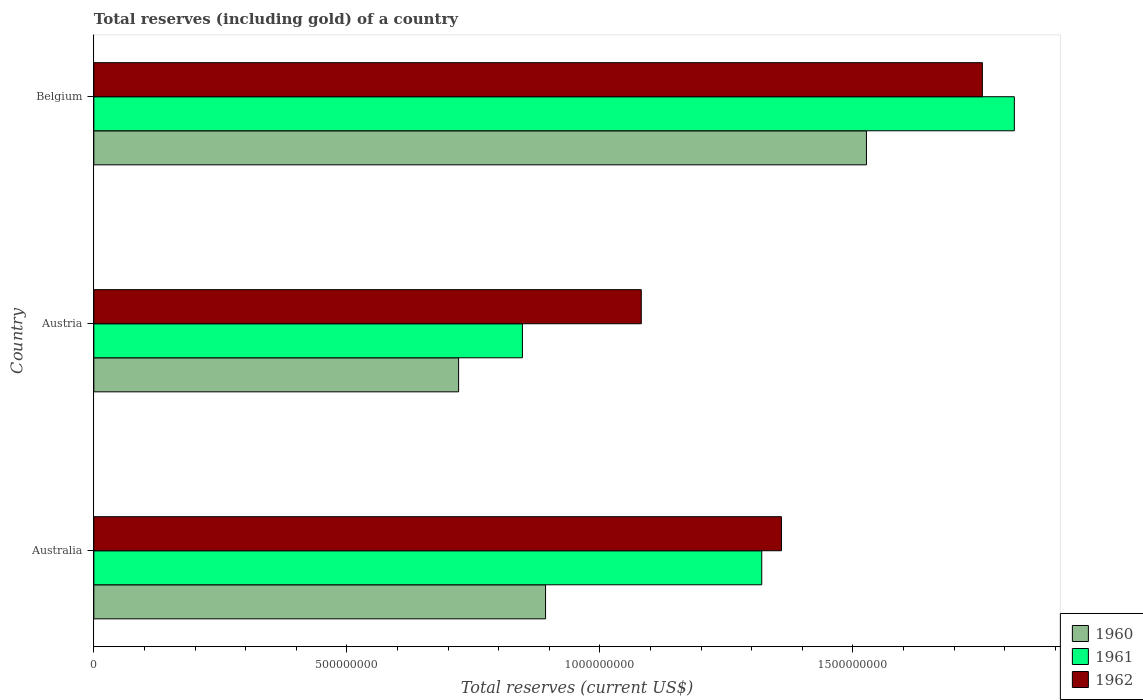Are the number of bars on each tick of the Y-axis equal?
Give a very brief answer. Yes. How many bars are there on the 1st tick from the top?
Your answer should be very brief. 3. How many bars are there on the 3rd tick from the bottom?
Provide a short and direct response. 3. What is the label of the 2nd group of bars from the top?
Ensure brevity in your answer.  Austria. In how many cases, is the number of bars for a given country not equal to the number of legend labels?
Provide a short and direct response. 0. What is the total reserves (including gold) in 1962 in Australia?
Your response must be concise. 1.36e+09. Across all countries, what is the maximum total reserves (including gold) in 1962?
Make the answer very short. 1.76e+09. Across all countries, what is the minimum total reserves (including gold) in 1962?
Give a very brief answer. 1.08e+09. In which country was the total reserves (including gold) in 1960 minimum?
Ensure brevity in your answer.  Austria. What is the total total reserves (including gold) in 1961 in the graph?
Offer a terse response. 3.99e+09. What is the difference between the total reserves (including gold) in 1960 in Australia and that in Belgium?
Your response must be concise. -6.34e+08. What is the difference between the total reserves (including gold) in 1961 in Australia and the total reserves (including gold) in 1962 in Belgium?
Ensure brevity in your answer.  -4.36e+08. What is the average total reserves (including gold) in 1962 per country?
Your answer should be compact. 1.40e+09. What is the difference between the total reserves (including gold) in 1960 and total reserves (including gold) in 1962 in Austria?
Your answer should be compact. -3.61e+08. What is the ratio of the total reserves (including gold) in 1961 in Austria to that in Belgium?
Provide a short and direct response. 0.47. What is the difference between the highest and the second highest total reserves (including gold) in 1961?
Make the answer very short. 4.99e+08. What is the difference between the highest and the lowest total reserves (including gold) in 1961?
Offer a very short reply. 9.72e+08. Is the sum of the total reserves (including gold) in 1960 in Austria and Belgium greater than the maximum total reserves (including gold) in 1962 across all countries?
Your response must be concise. Yes. What does the 1st bar from the top in Austria represents?
Provide a succinct answer. 1962. How many bars are there?
Provide a succinct answer. 9. Are all the bars in the graph horizontal?
Keep it short and to the point. Yes. Does the graph contain grids?
Your response must be concise. No. How many legend labels are there?
Offer a terse response. 3. How are the legend labels stacked?
Offer a very short reply. Vertical. What is the title of the graph?
Your answer should be very brief. Total reserves (including gold) of a country. What is the label or title of the X-axis?
Ensure brevity in your answer.  Total reserves (current US$). What is the Total reserves (current US$) in 1960 in Australia?
Ensure brevity in your answer.  8.93e+08. What is the Total reserves (current US$) in 1961 in Australia?
Ensure brevity in your answer.  1.32e+09. What is the Total reserves (current US$) in 1962 in Australia?
Offer a terse response. 1.36e+09. What is the Total reserves (current US$) in 1960 in Austria?
Provide a short and direct response. 7.21e+08. What is the Total reserves (current US$) of 1961 in Austria?
Your answer should be very brief. 8.47e+08. What is the Total reserves (current US$) in 1962 in Austria?
Your response must be concise. 1.08e+09. What is the Total reserves (current US$) in 1960 in Belgium?
Keep it short and to the point. 1.53e+09. What is the Total reserves (current US$) in 1961 in Belgium?
Keep it short and to the point. 1.82e+09. What is the Total reserves (current US$) in 1962 in Belgium?
Make the answer very short. 1.76e+09. Across all countries, what is the maximum Total reserves (current US$) of 1960?
Offer a terse response. 1.53e+09. Across all countries, what is the maximum Total reserves (current US$) in 1961?
Offer a terse response. 1.82e+09. Across all countries, what is the maximum Total reserves (current US$) in 1962?
Keep it short and to the point. 1.76e+09. Across all countries, what is the minimum Total reserves (current US$) in 1960?
Provide a succinct answer. 7.21e+08. Across all countries, what is the minimum Total reserves (current US$) of 1961?
Your answer should be compact. 8.47e+08. Across all countries, what is the minimum Total reserves (current US$) of 1962?
Provide a succinct answer. 1.08e+09. What is the total Total reserves (current US$) in 1960 in the graph?
Make the answer very short. 3.14e+09. What is the total Total reserves (current US$) in 1961 in the graph?
Make the answer very short. 3.99e+09. What is the total Total reserves (current US$) of 1962 in the graph?
Your response must be concise. 4.20e+09. What is the difference between the Total reserves (current US$) in 1960 in Australia and that in Austria?
Provide a short and direct response. 1.72e+08. What is the difference between the Total reserves (current US$) in 1961 in Australia and that in Austria?
Give a very brief answer. 4.73e+08. What is the difference between the Total reserves (current US$) in 1962 in Australia and that in Austria?
Provide a succinct answer. 2.77e+08. What is the difference between the Total reserves (current US$) in 1960 in Australia and that in Belgium?
Give a very brief answer. -6.34e+08. What is the difference between the Total reserves (current US$) in 1961 in Australia and that in Belgium?
Ensure brevity in your answer.  -4.99e+08. What is the difference between the Total reserves (current US$) of 1962 in Australia and that in Belgium?
Ensure brevity in your answer.  -3.97e+08. What is the difference between the Total reserves (current US$) in 1960 in Austria and that in Belgium?
Make the answer very short. -8.06e+08. What is the difference between the Total reserves (current US$) of 1961 in Austria and that in Belgium?
Provide a succinct answer. -9.72e+08. What is the difference between the Total reserves (current US$) in 1962 in Austria and that in Belgium?
Offer a very short reply. -6.74e+08. What is the difference between the Total reserves (current US$) in 1960 in Australia and the Total reserves (current US$) in 1961 in Austria?
Your answer should be very brief. 4.57e+07. What is the difference between the Total reserves (current US$) in 1960 in Australia and the Total reserves (current US$) in 1962 in Austria?
Offer a terse response. -1.89e+08. What is the difference between the Total reserves (current US$) of 1961 in Australia and the Total reserves (current US$) of 1962 in Austria?
Give a very brief answer. 2.38e+08. What is the difference between the Total reserves (current US$) in 1960 in Australia and the Total reserves (current US$) in 1961 in Belgium?
Keep it short and to the point. -9.26e+08. What is the difference between the Total reserves (current US$) of 1960 in Australia and the Total reserves (current US$) of 1962 in Belgium?
Give a very brief answer. -8.63e+08. What is the difference between the Total reserves (current US$) of 1961 in Australia and the Total reserves (current US$) of 1962 in Belgium?
Provide a short and direct response. -4.36e+08. What is the difference between the Total reserves (current US$) in 1960 in Austria and the Total reserves (current US$) in 1961 in Belgium?
Make the answer very short. -1.10e+09. What is the difference between the Total reserves (current US$) in 1960 in Austria and the Total reserves (current US$) in 1962 in Belgium?
Your answer should be compact. -1.04e+09. What is the difference between the Total reserves (current US$) of 1961 in Austria and the Total reserves (current US$) of 1962 in Belgium?
Your answer should be very brief. -9.09e+08. What is the average Total reserves (current US$) of 1960 per country?
Give a very brief answer. 1.05e+09. What is the average Total reserves (current US$) of 1961 per country?
Make the answer very short. 1.33e+09. What is the average Total reserves (current US$) of 1962 per country?
Offer a very short reply. 1.40e+09. What is the difference between the Total reserves (current US$) in 1960 and Total reserves (current US$) in 1961 in Australia?
Provide a short and direct response. -4.27e+08. What is the difference between the Total reserves (current US$) of 1960 and Total reserves (current US$) of 1962 in Australia?
Your answer should be compact. -4.66e+08. What is the difference between the Total reserves (current US$) in 1961 and Total reserves (current US$) in 1962 in Australia?
Provide a short and direct response. -3.89e+07. What is the difference between the Total reserves (current US$) in 1960 and Total reserves (current US$) in 1961 in Austria?
Keep it short and to the point. -1.26e+08. What is the difference between the Total reserves (current US$) of 1960 and Total reserves (current US$) of 1962 in Austria?
Give a very brief answer. -3.61e+08. What is the difference between the Total reserves (current US$) of 1961 and Total reserves (current US$) of 1962 in Austria?
Your answer should be very brief. -2.35e+08. What is the difference between the Total reserves (current US$) in 1960 and Total reserves (current US$) in 1961 in Belgium?
Provide a succinct answer. -2.92e+08. What is the difference between the Total reserves (current US$) in 1960 and Total reserves (current US$) in 1962 in Belgium?
Make the answer very short. -2.29e+08. What is the difference between the Total reserves (current US$) of 1961 and Total reserves (current US$) of 1962 in Belgium?
Make the answer very short. 6.32e+07. What is the ratio of the Total reserves (current US$) in 1960 in Australia to that in Austria?
Keep it short and to the point. 1.24. What is the ratio of the Total reserves (current US$) of 1961 in Australia to that in Austria?
Your answer should be compact. 1.56. What is the ratio of the Total reserves (current US$) of 1962 in Australia to that in Austria?
Keep it short and to the point. 1.26. What is the ratio of the Total reserves (current US$) of 1960 in Australia to that in Belgium?
Give a very brief answer. 0.58. What is the ratio of the Total reserves (current US$) in 1961 in Australia to that in Belgium?
Your answer should be very brief. 0.73. What is the ratio of the Total reserves (current US$) in 1962 in Australia to that in Belgium?
Offer a very short reply. 0.77. What is the ratio of the Total reserves (current US$) of 1960 in Austria to that in Belgium?
Give a very brief answer. 0.47. What is the ratio of the Total reserves (current US$) in 1961 in Austria to that in Belgium?
Your answer should be compact. 0.47. What is the ratio of the Total reserves (current US$) in 1962 in Austria to that in Belgium?
Offer a terse response. 0.62. What is the difference between the highest and the second highest Total reserves (current US$) in 1960?
Your answer should be compact. 6.34e+08. What is the difference between the highest and the second highest Total reserves (current US$) in 1961?
Your answer should be very brief. 4.99e+08. What is the difference between the highest and the second highest Total reserves (current US$) of 1962?
Make the answer very short. 3.97e+08. What is the difference between the highest and the lowest Total reserves (current US$) in 1960?
Your answer should be very brief. 8.06e+08. What is the difference between the highest and the lowest Total reserves (current US$) in 1961?
Provide a succinct answer. 9.72e+08. What is the difference between the highest and the lowest Total reserves (current US$) in 1962?
Ensure brevity in your answer.  6.74e+08. 